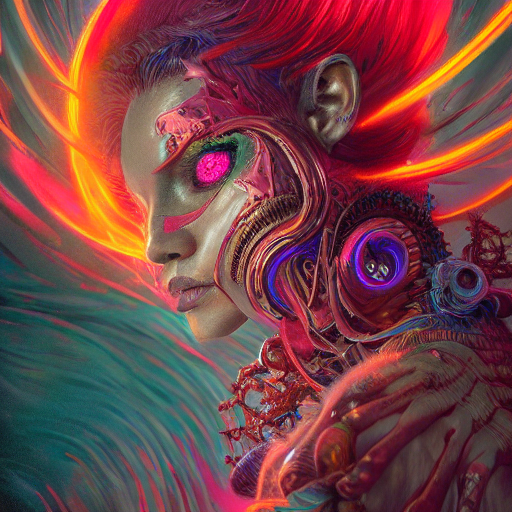Are there any quality issues with this image? The image appears to be of high quality with vivid colors and intricate details, particularly in the mechanical components and the subject's textured skin. There don't seem to be any glaring quality issues regarding resolution or visual artifacts. 